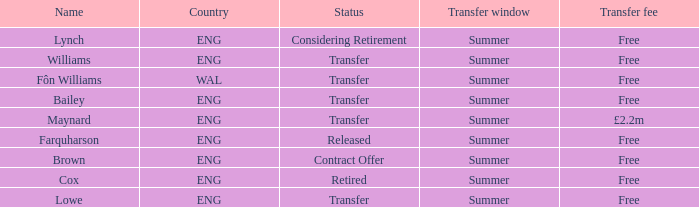What is the state of the eng country associated with the maynard name? Transfer. 